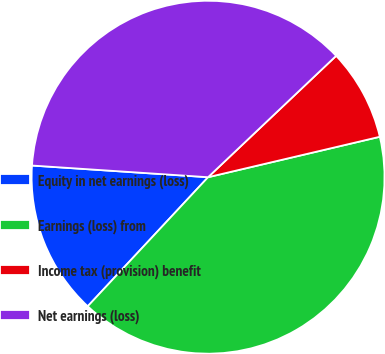Convert chart. <chart><loc_0><loc_0><loc_500><loc_500><pie_chart><fcel>Equity in net earnings (loss)<fcel>Earnings (loss) from<fcel>Income tax (provision) benefit<fcel>Net earnings (loss)<nl><fcel>14.11%<fcel>40.62%<fcel>8.39%<fcel>36.87%<nl></chart> 